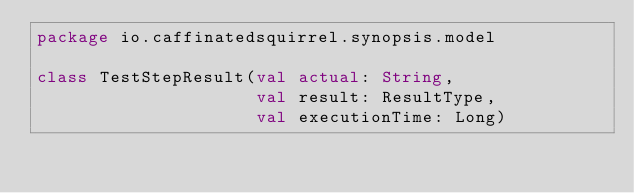<code> <loc_0><loc_0><loc_500><loc_500><_Kotlin_>package io.caffinatedsquirrel.synopsis.model

class TestStepResult(val actual: String,
                     val result: ResultType,
                     val executionTime: Long)</code> 